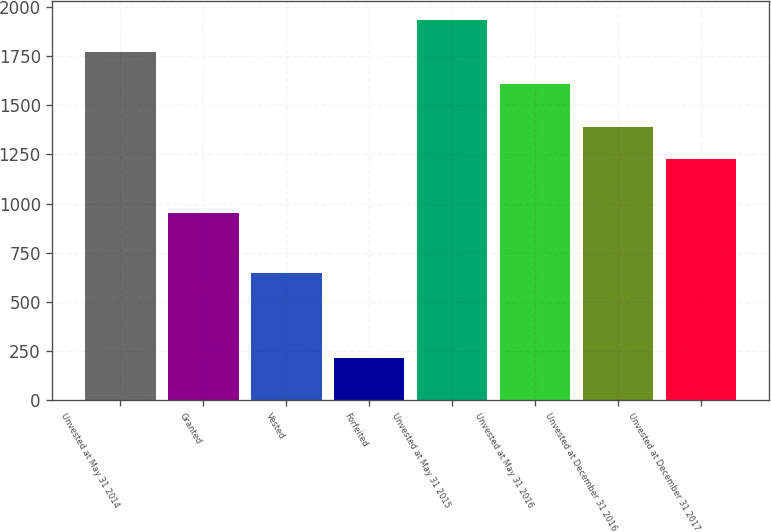Convert chart to OTSL. <chart><loc_0><loc_0><loc_500><loc_500><bar_chart><fcel>Unvested at May 31 2014<fcel>Granted<fcel>Vested<fcel>Forfeited<fcel>Unvested at May 31 2015<fcel>Unvested at May 31 2016<fcel>Unvested at December 31 2016<fcel>Unvested at December 31 2017<nl><fcel>1769.6<fcel>954<fcel>648<fcel>212<fcel>1933.2<fcel>1606<fcel>1389.6<fcel>1226<nl></chart> 